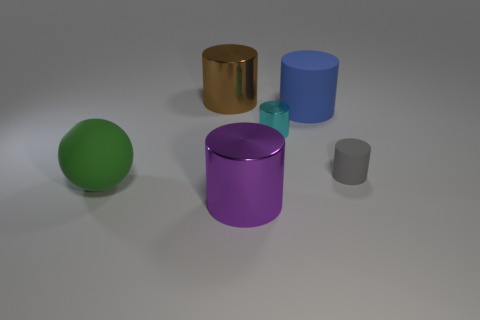Subtract all gray cylinders. How many cylinders are left? 4 Subtract all small matte cylinders. How many cylinders are left? 4 Subtract all yellow cylinders. Subtract all yellow cubes. How many cylinders are left? 5 Add 3 shiny cylinders. How many objects exist? 9 Subtract all spheres. How many objects are left? 5 Subtract all large brown objects. Subtract all big brown cylinders. How many objects are left? 4 Add 2 large metal things. How many large metal things are left? 4 Add 3 small red balls. How many small red balls exist? 3 Subtract 0 gray spheres. How many objects are left? 6 